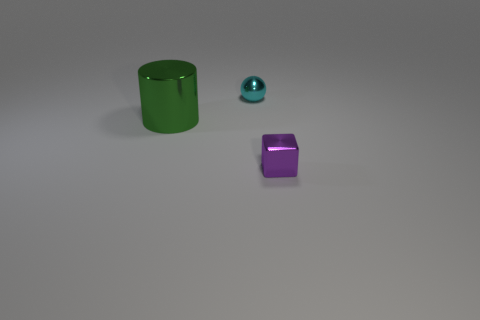Add 1 purple metallic things. How many objects exist? 4 Subtract all spheres. How many objects are left? 2 Subtract all purple shiny cubes. Subtract all metal balls. How many objects are left? 1 Add 3 large green metallic objects. How many large green metallic objects are left? 4 Add 2 big gray rubber spheres. How many big gray rubber spheres exist? 2 Subtract 0 yellow cylinders. How many objects are left? 3 